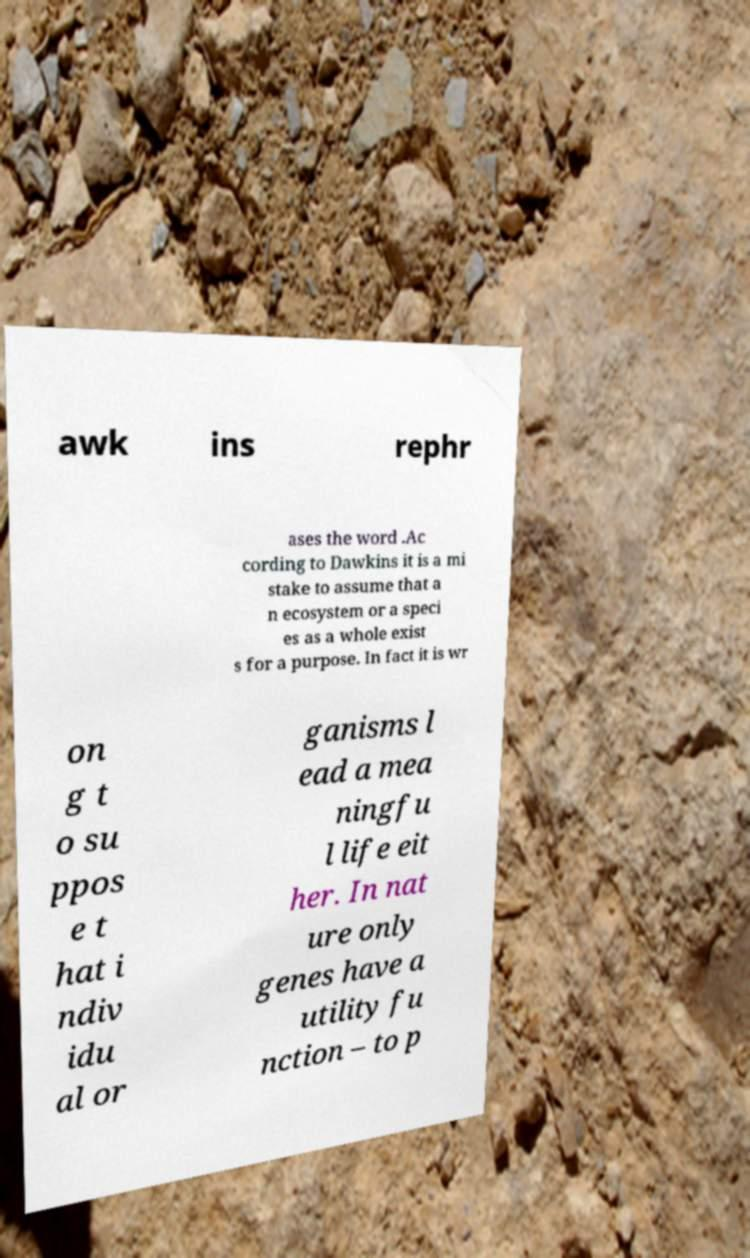Could you assist in decoding the text presented in this image and type it out clearly? awk ins rephr ases the word .Ac cording to Dawkins it is a mi stake to assume that a n ecosystem or a speci es as a whole exist s for a purpose. In fact it is wr on g t o su ppos e t hat i ndiv idu al or ganisms l ead a mea ningfu l life eit her. In nat ure only genes have a utility fu nction – to p 